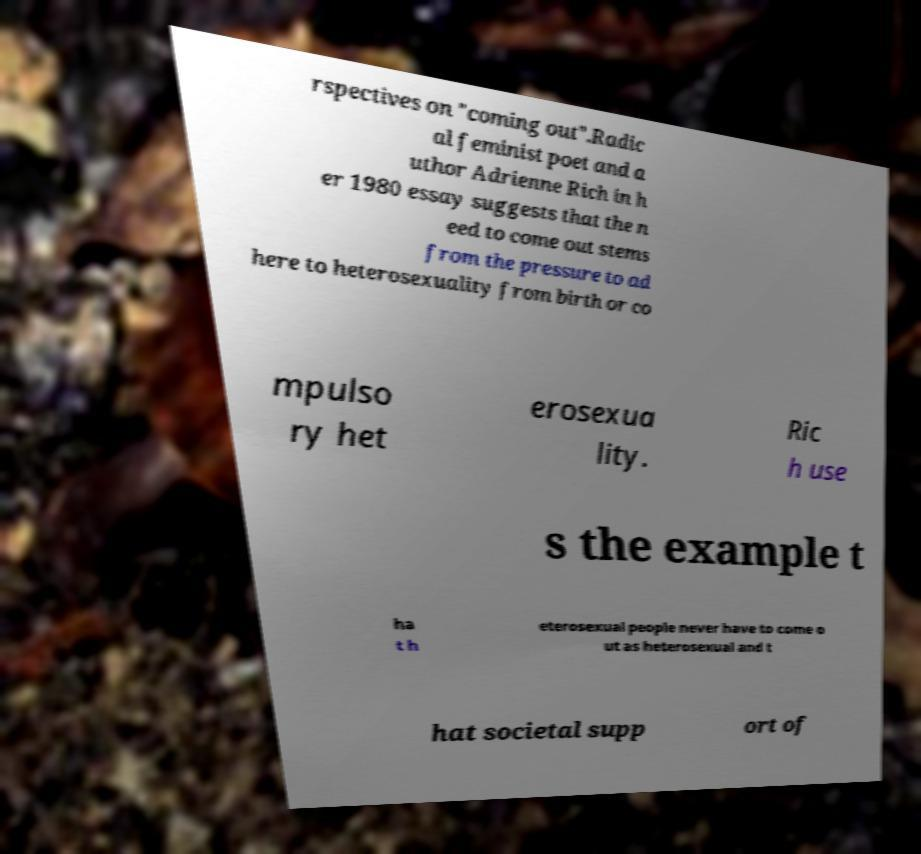Could you assist in decoding the text presented in this image and type it out clearly? rspectives on "coming out".Radic al feminist poet and a uthor Adrienne Rich in h er 1980 essay suggests that the n eed to come out stems from the pressure to ad here to heterosexuality from birth or co mpulso ry het erosexua lity. Ric h use s the example t ha t h eterosexual people never have to come o ut as heterosexual and t hat societal supp ort of 